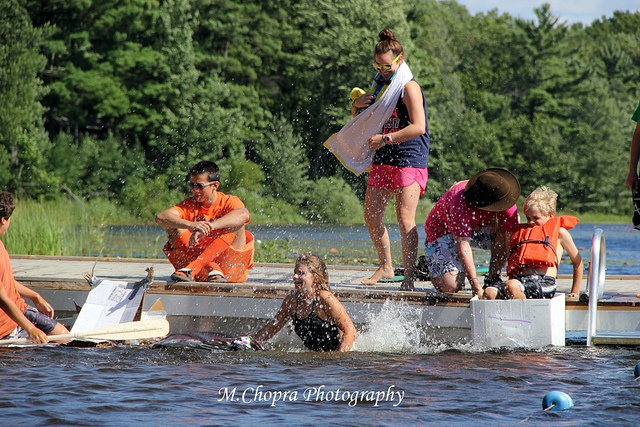Describe the objects in this image and their specific colors. I can see boat in black, darkgray, lightgray, and gray tones, people in black, gray, and maroon tones, people in black, maroon, and gray tones, people in black, red, maroon, salmon, and brown tones, and boat in black, white, darkgray, and gray tones in this image. 